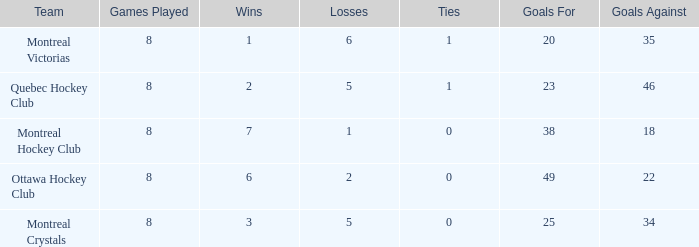What is the highest goals against when the wins is less than 1? None. 